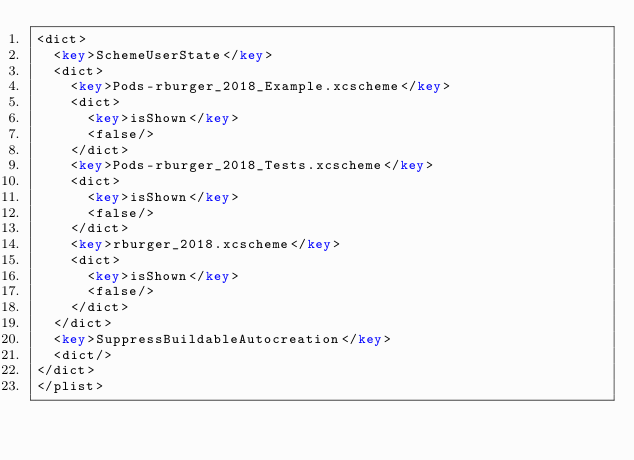Convert code to text. <code><loc_0><loc_0><loc_500><loc_500><_XML_><dict>
	<key>SchemeUserState</key>
	<dict>
		<key>Pods-rburger_2018_Example.xcscheme</key>
		<dict>
			<key>isShown</key>
			<false/>
		</dict>
		<key>Pods-rburger_2018_Tests.xcscheme</key>
		<dict>
			<key>isShown</key>
			<false/>
		</dict>
		<key>rburger_2018.xcscheme</key>
		<dict>
			<key>isShown</key>
			<false/>
		</dict>
	</dict>
	<key>SuppressBuildableAutocreation</key>
	<dict/>
</dict>
</plist>
</code> 